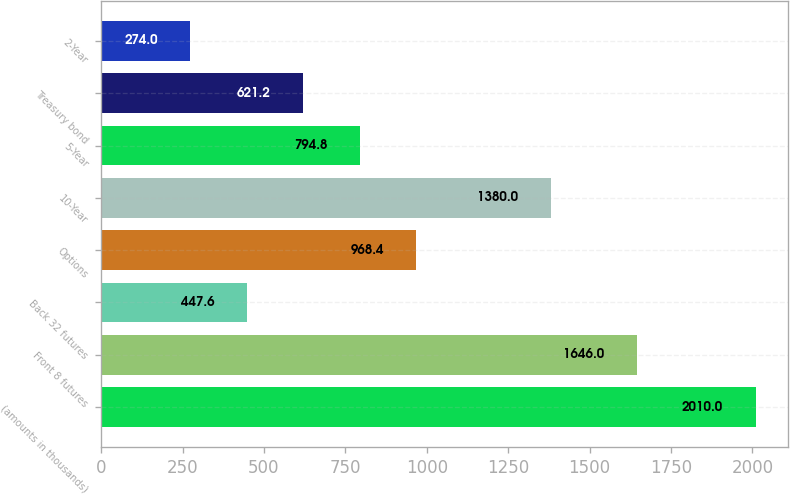Convert chart. <chart><loc_0><loc_0><loc_500><loc_500><bar_chart><fcel>(amounts in thousands)<fcel>Front 8 futures<fcel>Back 32 futures<fcel>Options<fcel>10-Year<fcel>5-Year<fcel>Treasury bond<fcel>2-Year<nl><fcel>2010<fcel>1646<fcel>447.6<fcel>968.4<fcel>1380<fcel>794.8<fcel>621.2<fcel>274<nl></chart> 